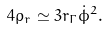Convert formula to latex. <formula><loc_0><loc_0><loc_500><loc_500>4 \rho _ { r } \simeq 3 r _ { \Gamma } \dot { \phi } ^ { 2 } .</formula> 